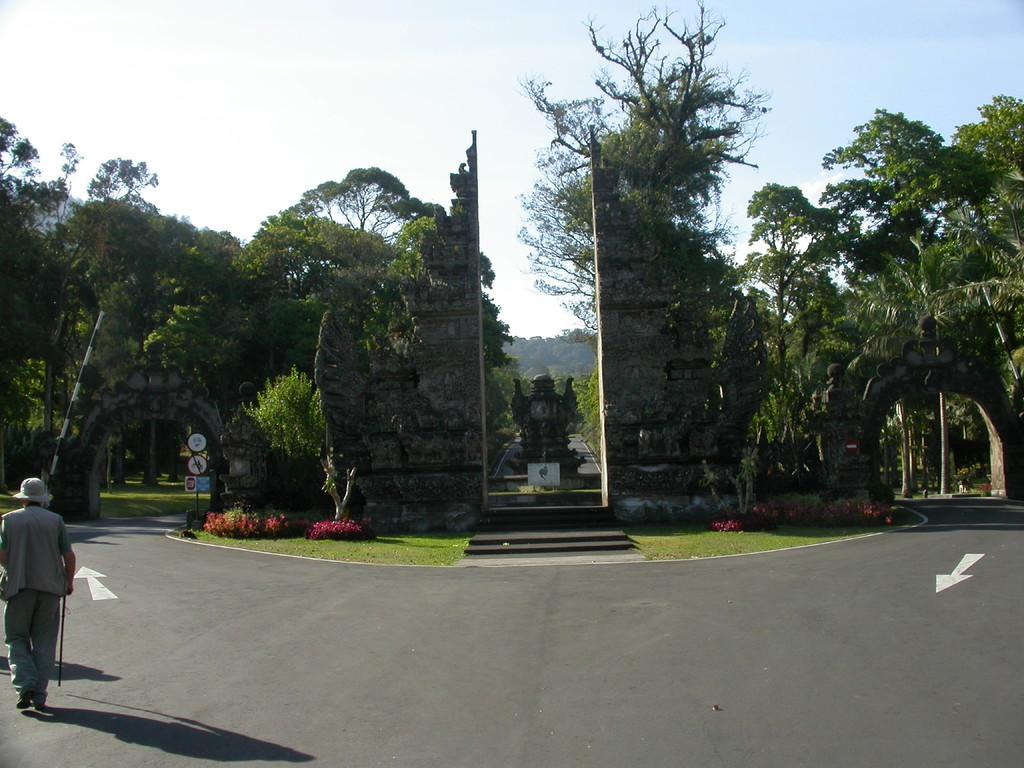What is the main subject of the image? There is a person on the road in the image. What type of natural environment is visible in the image? There is grass, plants, trees, and the sky visible in the image. What man-made objects can be seen in the image? There are boards, a pole, and a sculpture in the image. What type of event is taking place in the image? There is no indication of an event taking place in the image. Is there a farmer present in the image? There is no farmer present in the image. What is the acoustics like in the image? The concept of acoustics is not relevant to the image, as it does not depict any sound-related elements or activities. 